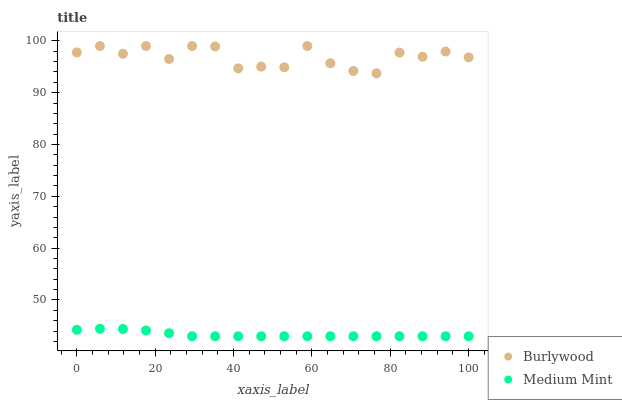Does Medium Mint have the minimum area under the curve?
Answer yes or no. Yes. Does Burlywood have the maximum area under the curve?
Answer yes or no. Yes. Does Medium Mint have the maximum area under the curve?
Answer yes or no. No. Is Medium Mint the smoothest?
Answer yes or no. Yes. Is Burlywood the roughest?
Answer yes or no. Yes. Is Medium Mint the roughest?
Answer yes or no. No. Does Medium Mint have the lowest value?
Answer yes or no. Yes. Does Burlywood have the highest value?
Answer yes or no. Yes. Does Medium Mint have the highest value?
Answer yes or no. No. Is Medium Mint less than Burlywood?
Answer yes or no. Yes. Is Burlywood greater than Medium Mint?
Answer yes or no. Yes. Does Medium Mint intersect Burlywood?
Answer yes or no. No. 